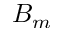<formula> <loc_0><loc_0><loc_500><loc_500>B _ { m }</formula> 